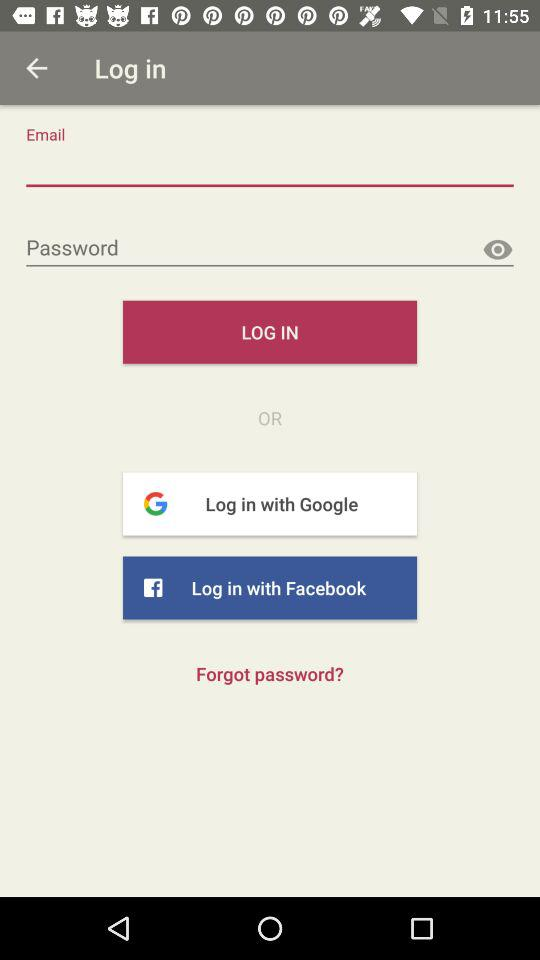How many characters are required to create a password?
When the provided information is insufficient, respond with <no answer>. <no answer> 